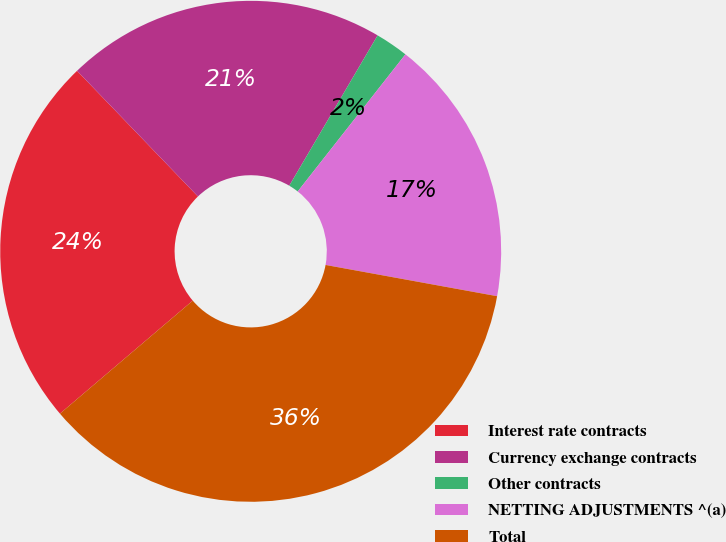Convert chart. <chart><loc_0><loc_0><loc_500><loc_500><pie_chart><fcel>Interest rate contracts<fcel>Currency exchange contracts<fcel>Other contracts<fcel>NETTING ADJUSTMENTS ^(a)<fcel>Total<nl><fcel>24.03%<fcel>20.65%<fcel>2.14%<fcel>17.27%<fcel>35.91%<nl></chart> 